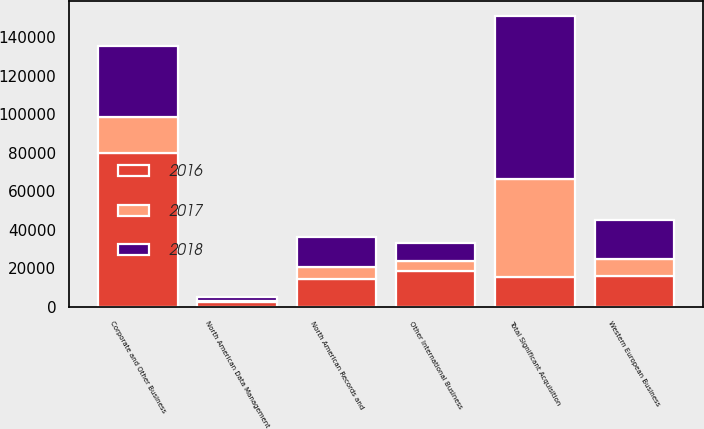<chart> <loc_0><loc_0><loc_500><loc_500><stacked_bar_chart><ecel><fcel>North American Records and<fcel>North American Data Management<fcel>Western European Business<fcel>Other International Business<fcel>Corporate and Other Business<fcel>Total Significant Acquisition<nl><fcel>2016<fcel>14394<fcel>2581<fcel>16173<fcel>18842<fcel>79954<fcel>15763<nl><fcel>2018<fcel>15763<fcel>2099<fcel>20290<fcel>9570<fcel>37179<fcel>84901<nl><fcel>2017<fcel>6202<fcel>637<fcel>8852<fcel>4899<fcel>18652<fcel>50665<nl></chart> 